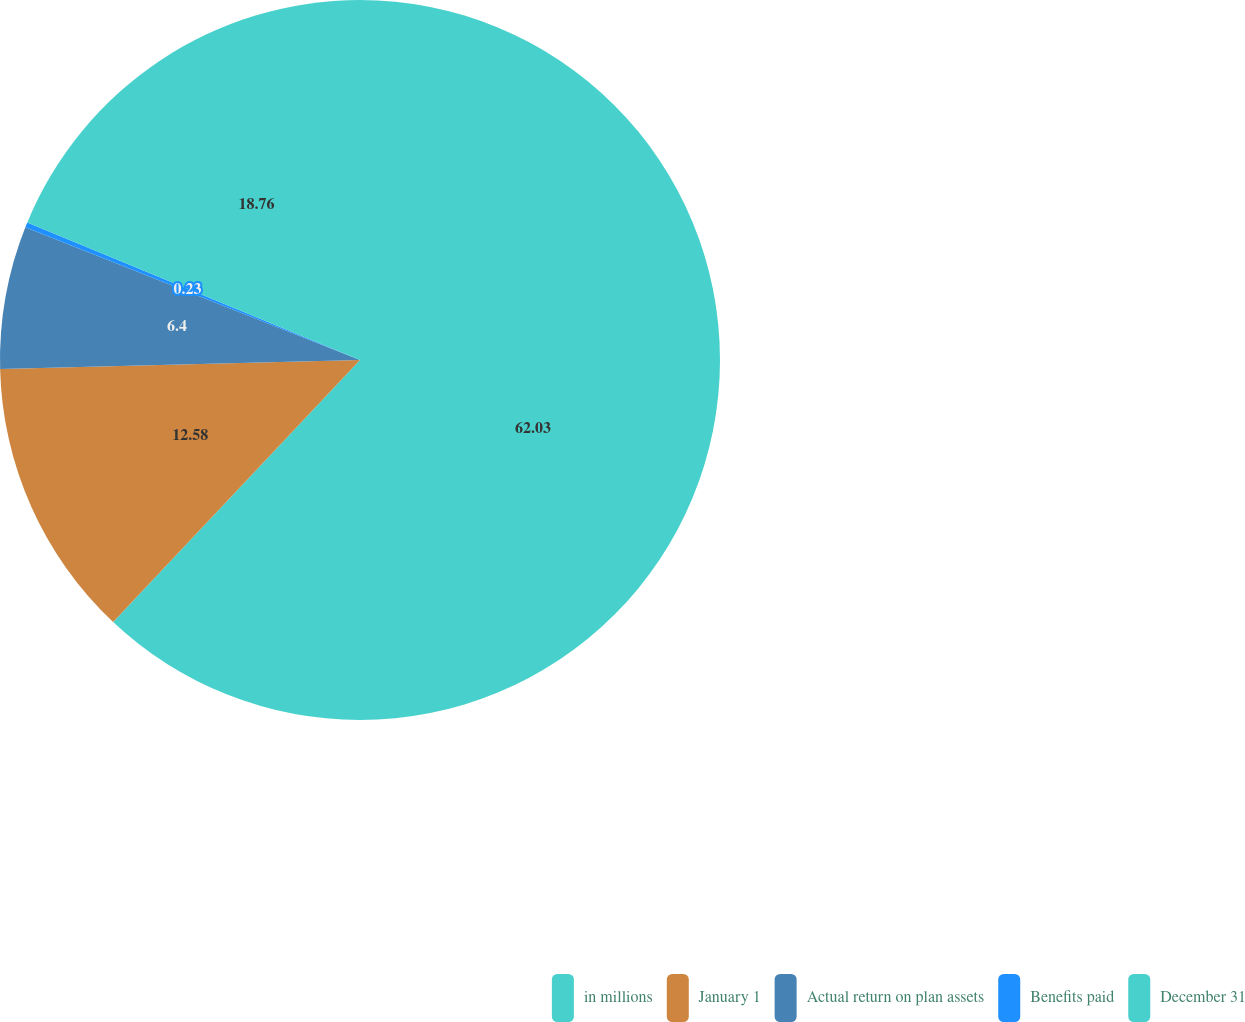<chart> <loc_0><loc_0><loc_500><loc_500><pie_chart><fcel>in millions<fcel>January 1<fcel>Actual return on plan assets<fcel>Benefits paid<fcel>December 31<nl><fcel>62.02%<fcel>12.58%<fcel>6.4%<fcel>0.23%<fcel>18.76%<nl></chart> 